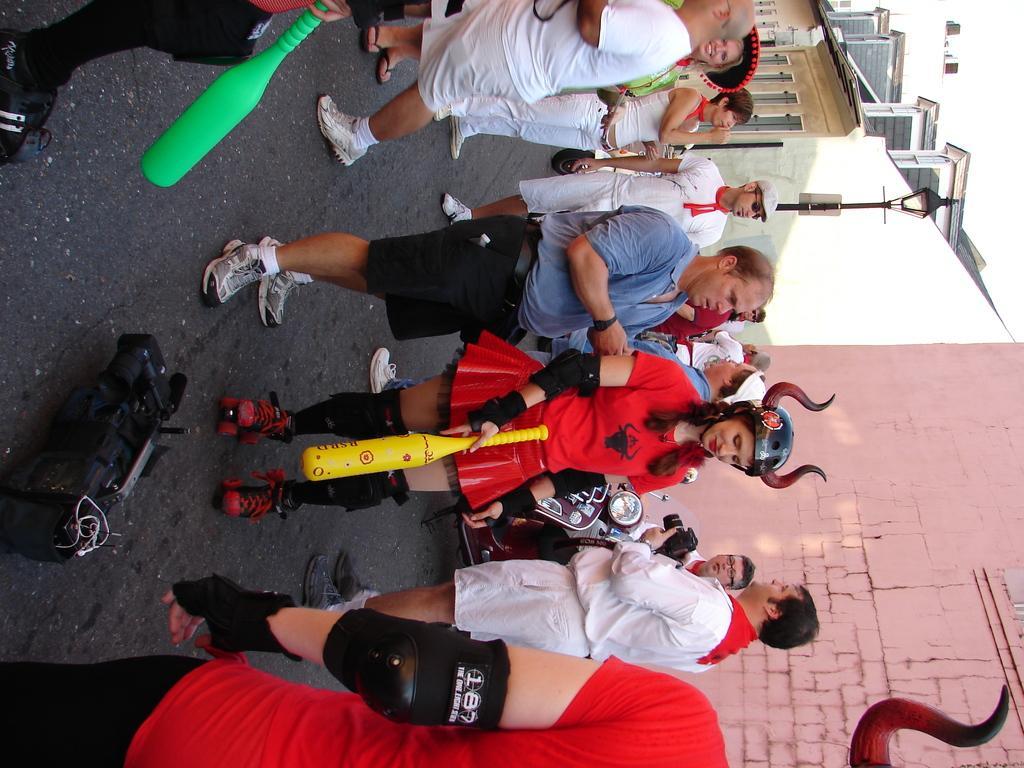In one or two sentences, can you explain what this image depicts? In this picture we can see a group of people and an object on the ground and two people are holding bats and in the background we can see the wall and some objects. 